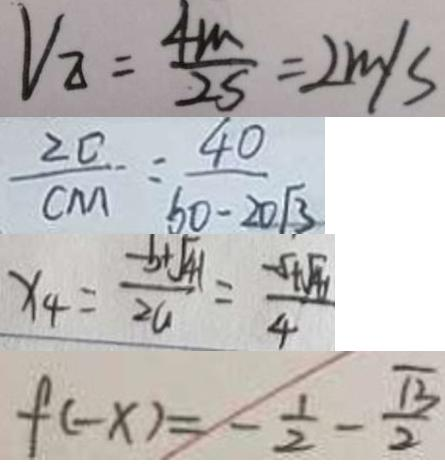Convert formula to latex. <formula><loc_0><loc_0><loc_500><loc_500>V _ { \Delta } = \frac { 4 m } { 2 S } = 2 m / s 
 \frac { 2 0 } { C M } = \frac { 4 0 } { 6 0 - 2 0 \sqrt { 3 } } 
 x _ { 4 } = \frac { - b + \sqrt { 4 1 } } { 2 a } = \frac { - 5 + \sqrt { 4 1 } } { 4 } 
 f ( - x ) = - \frac { 1 } { 2 } - \frac { \sqrt { 3 } } { 2 }</formula> 